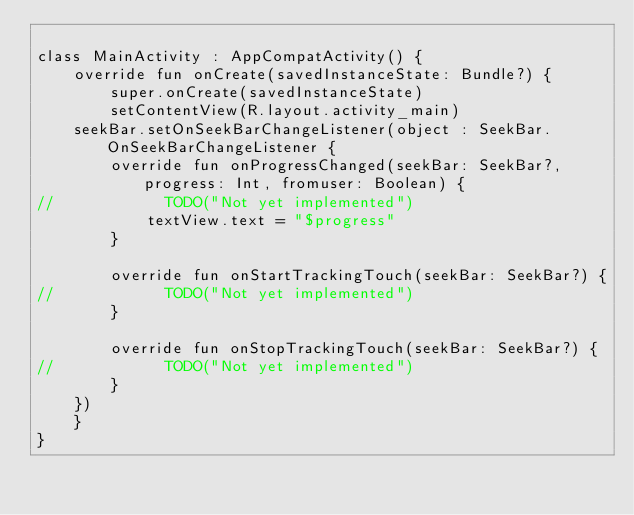Convert code to text. <code><loc_0><loc_0><loc_500><loc_500><_Kotlin_>
class MainActivity : AppCompatActivity() {
    override fun onCreate(savedInstanceState: Bundle?) {
        super.onCreate(savedInstanceState)
        setContentView(R.layout.activity_main)
    seekBar.setOnSeekBarChangeListener(object : SeekBar.OnSeekBarChangeListener {
        override fun onProgressChanged(seekBar: SeekBar?, progress: Int, fromuser: Boolean) {
//            TODO("Not yet implemented")
            textView.text = "$progress"
        }

        override fun onStartTrackingTouch(seekBar: SeekBar?) {
//            TODO("Not yet implemented")
        }

        override fun onStopTrackingTouch(seekBar: SeekBar?) {
//            TODO("Not yet implemented")
        }
    })
    }
}

</code> 